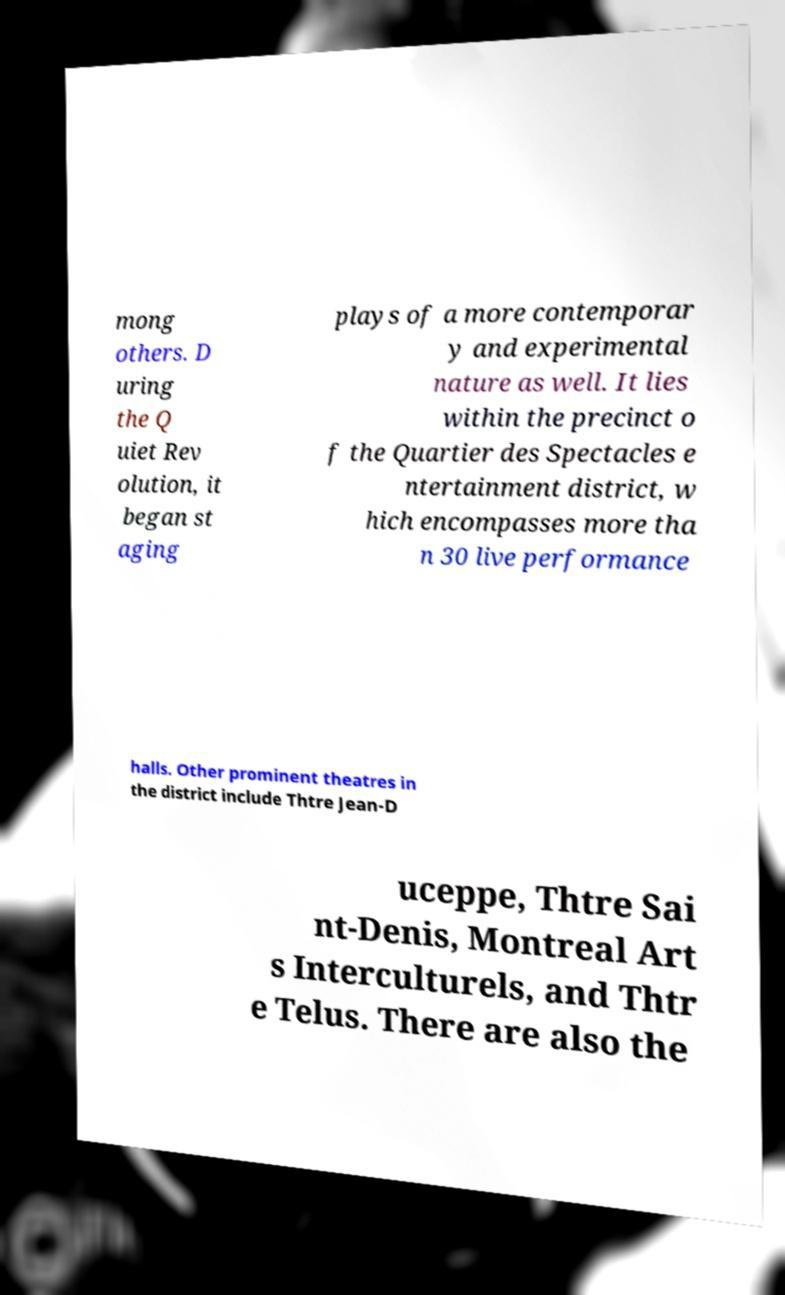Could you assist in decoding the text presented in this image and type it out clearly? mong others. D uring the Q uiet Rev olution, it began st aging plays of a more contemporar y and experimental nature as well. It lies within the precinct o f the Quartier des Spectacles e ntertainment district, w hich encompasses more tha n 30 live performance halls. Other prominent theatres in the district include Thtre Jean-D uceppe, Thtre Sai nt-Denis, Montreal Art s Interculturels, and Thtr e Telus. There are also the 